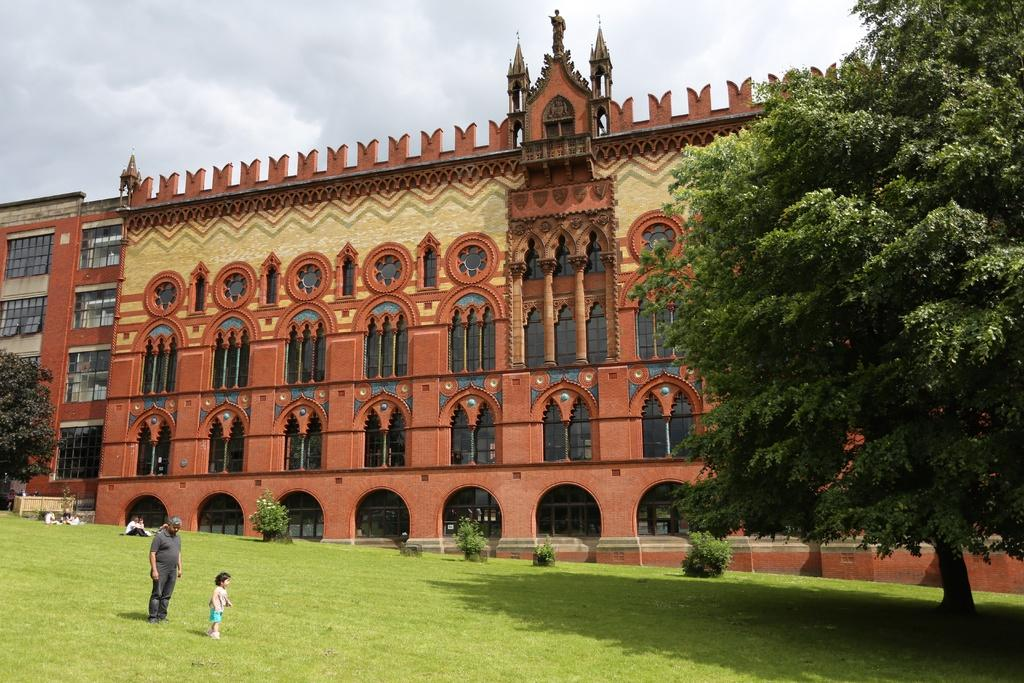What are the people in the image doing? The persons in the image are sitting and standing on the ground. What can be seen in the background of the image? There are buildings, trees, a statue, bushes, and the sky visible in the background of the image. What is the condition of the sky in the image? The sky is visible in the background of the image, and clouds are present. What type of locket is hanging from the statue in the image? There is no locket present on the statue in the image. Can you tell me how many berries are growing on the trees in the image? There is no mention of berries in the image, as it only describes trees and other background elements. 